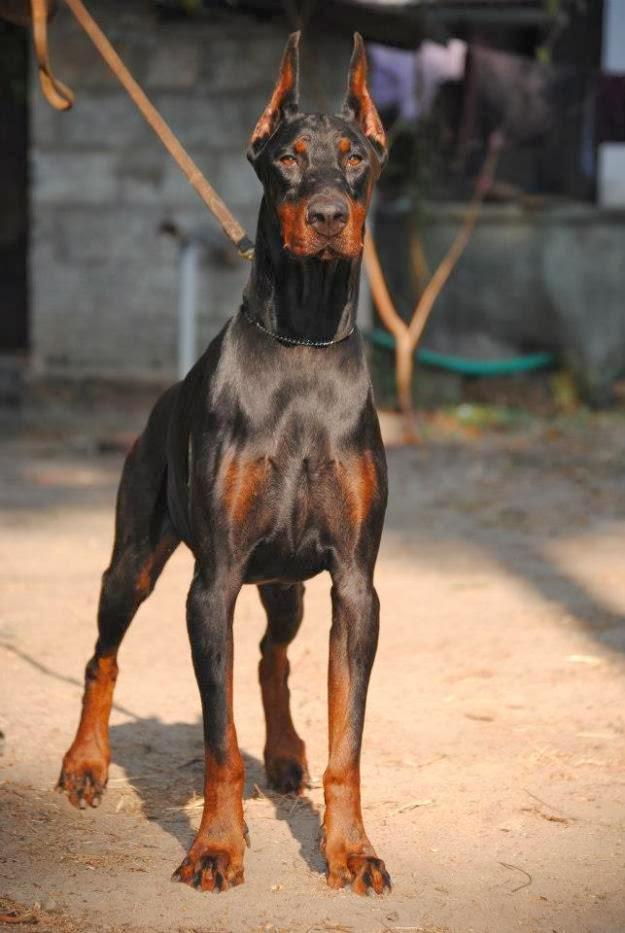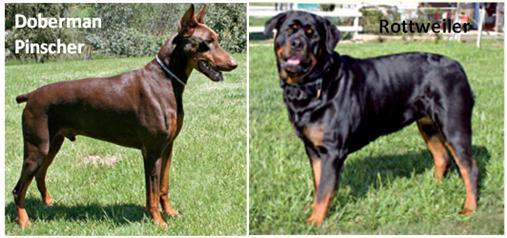The first image is the image on the left, the second image is the image on the right. Assess this claim about the two images: "A total of three dogs, all standing, are shown, and at least two dogs are dobermans with erect pointy ears.". Correct or not? Answer yes or no. Yes. The first image is the image on the left, the second image is the image on the right. For the images shown, is this caption "There are three dogs." true? Answer yes or no. Yes. 